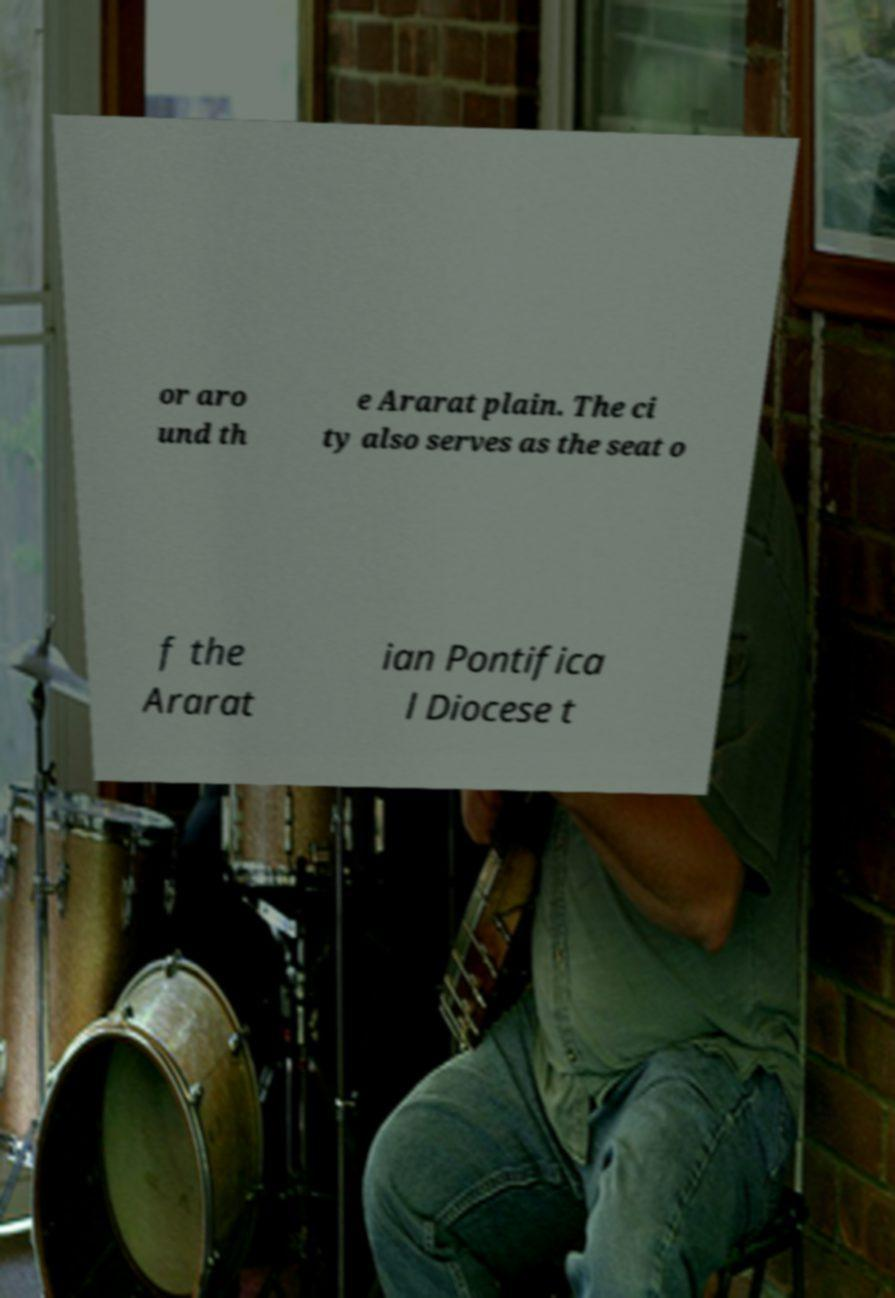Can you read and provide the text displayed in the image?This photo seems to have some interesting text. Can you extract and type it out for me? or aro und th e Ararat plain. The ci ty also serves as the seat o f the Ararat ian Pontifica l Diocese t 